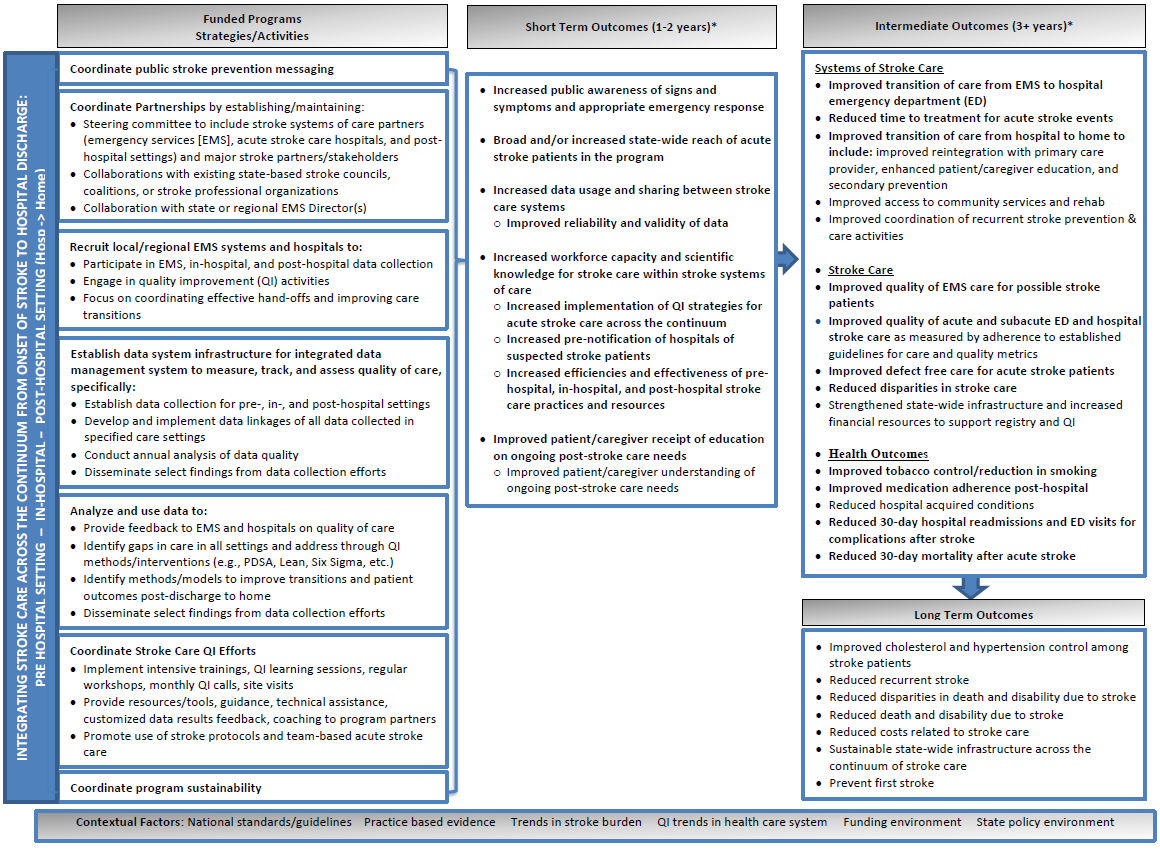Considering the structure and content of this strategic plan, what might be the potential challenges in coordinating public stroke prevention messaging across multiple stakeholders as outlined in the "Funded Programs Strategies/Activities" section? Based on the strategic plan's structure, coordinating stroke prevention messaging across multiple stakeholders poses various challenges. Managing diverse committees and ensuring consistent messaging across emergency care, hospitals, and post-hospital levels requires tight integration. Adding to this complexity, there's a need for effective collaboration with existing stroke councils and professional organizations. The plan also highlights the challenge in maintaining engagement and aligning activities with national guidelines as per the 'Contextual Factors' section. To efficiently tackle these challenges, it's crucial to focus on improved data sharing between care systems, as well as enhanced training and guidance for all parties involved, thus facilitating a robust foundation for implementing state-wide strategies effectively. 